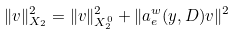<formula> <loc_0><loc_0><loc_500><loc_500>\| v \| _ { X _ { 2 } } ^ { 2 } = \| v \| _ { X _ { 2 } ^ { 0 } } ^ { 2 } + \| a _ { e } ^ { w } ( y , D ) v \| ^ { 2 }</formula> 